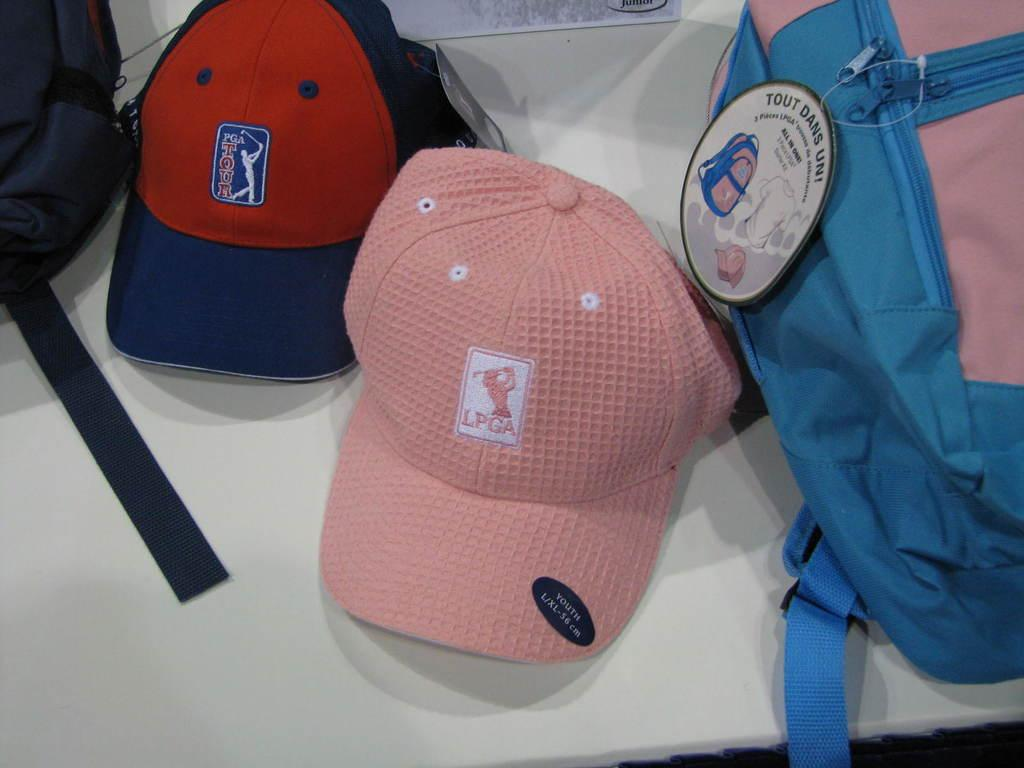Provide a one-sentence caption for the provided image. Two PGA caps are next to a pink and blue bag. 